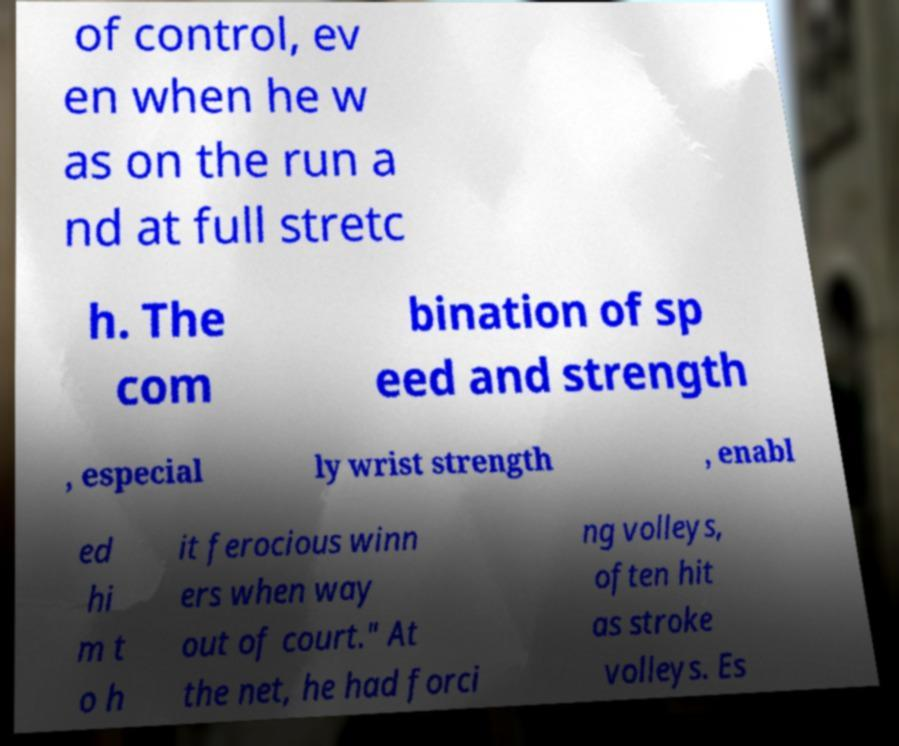For documentation purposes, I need the text within this image transcribed. Could you provide that? of control, ev en when he w as on the run a nd at full stretc h. The com bination of sp eed and strength , especial ly wrist strength , enabl ed hi m t o h it ferocious winn ers when way out of court." At the net, he had forci ng volleys, often hit as stroke volleys. Es 